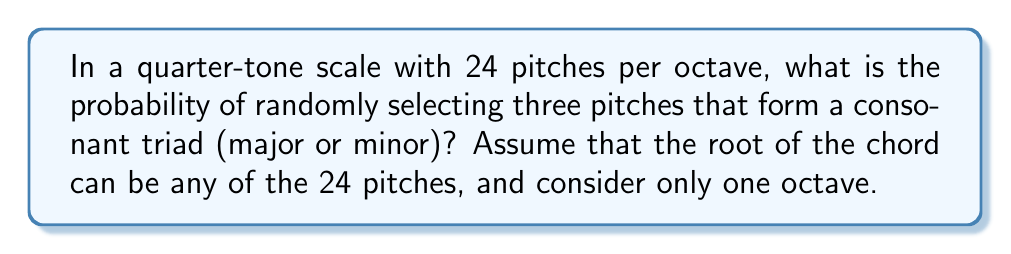Solve this math problem. Let's approach this step-by-step:

1) In a quarter-tone scale, there are 24 pitches per octave instead of the usual 12 in a standard chromatic scale.

2) For a consonant triad, we need three notes: the root, the third (major or minor), and the perfect fifth.

3) In a quarter-tone scale:
   - A major third is 10 quarter-tones above the root
   - A minor third is 8 quarter-tones above the root
   - A perfect fifth is 14 quarter-tones above the root

4) For each root, we have two possible consonant triads (major and minor). So, we need to calculate:

   $$P(\text{consonant triad}) = \frac{\text{number of consonant triads}}{\text{total number of possible three-note combinations}}$$

5) Number of consonant triads:
   - There are 24 possible roots
   - For each root, there are 2 consonant triads (major and minor)
   - Total number of consonant triads = $24 \times 2 = 48$

6) Total number of possible three-note combinations:
   - We're selecting 3 notes out of 24, where order doesn't matter and repetition is not allowed
   - This is a combination problem: $\binom{24}{3}$
   - $\binom{24}{3} = \frac{24!}{3!(24-3)!} = \frac{24!}{3!21!} = 2024$

7) Therefore, the probability is:

   $$P(\text{consonant triad}) = \frac{48}{2024} = \frac{6}{253} \approx 0.0237$$
Answer: $\frac{6}{253}$ 